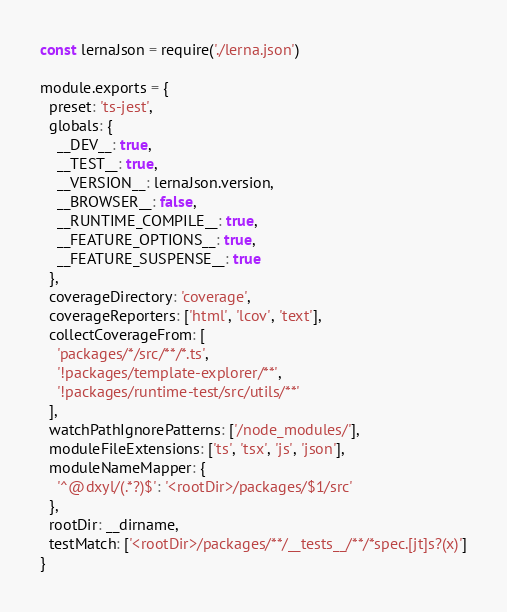Convert code to text. <code><loc_0><loc_0><loc_500><loc_500><_JavaScript_>const lernaJson = require('./lerna.json')

module.exports = {
  preset: 'ts-jest',
  globals: {
    __DEV__: true,
    __TEST__: true,
    __VERSION__: lernaJson.version,
    __BROWSER__: false,
    __RUNTIME_COMPILE__: true,
    __FEATURE_OPTIONS__: true,
    __FEATURE_SUSPENSE__: true
  },
  coverageDirectory: 'coverage',
  coverageReporters: ['html', 'lcov', 'text'],
  collectCoverageFrom: [
    'packages/*/src/**/*.ts',
    '!packages/template-explorer/**',
    '!packages/runtime-test/src/utils/**'
  ],
  watchPathIgnorePatterns: ['/node_modules/'],
  moduleFileExtensions: ['ts', 'tsx', 'js', 'json'],
  moduleNameMapper: {
    '^@dxyl/(.*?)$': '<rootDir>/packages/$1/src'
  },
  rootDir: __dirname,
  testMatch: ['<rootDir>/packages/**/__tests__/**/*spec.[jt]s?(x)']
}
</code> 